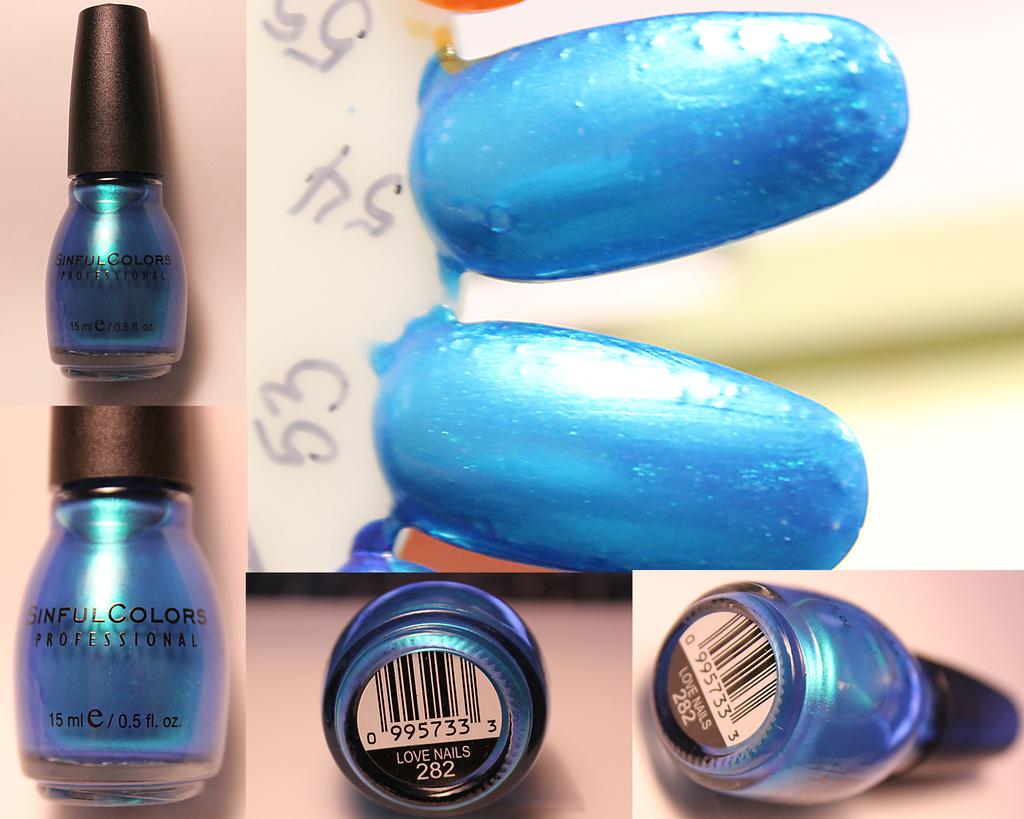What brand of nail polish is this?
Give a very brief answer. Sinful colors. What is the color name?
Offer a very short reply. Sinful colors. 